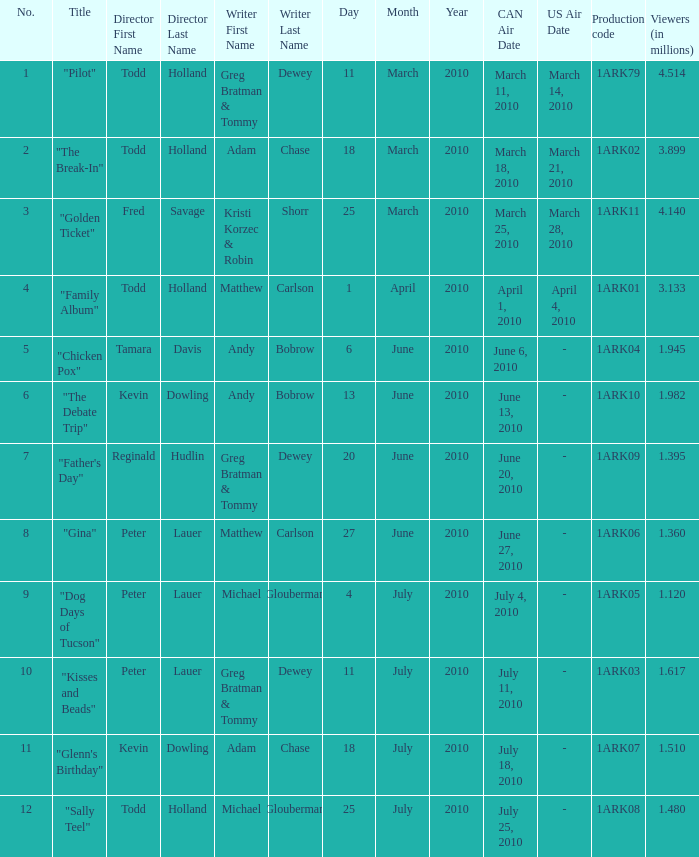How many directors were there for the production code 1ark08? 1.0. 